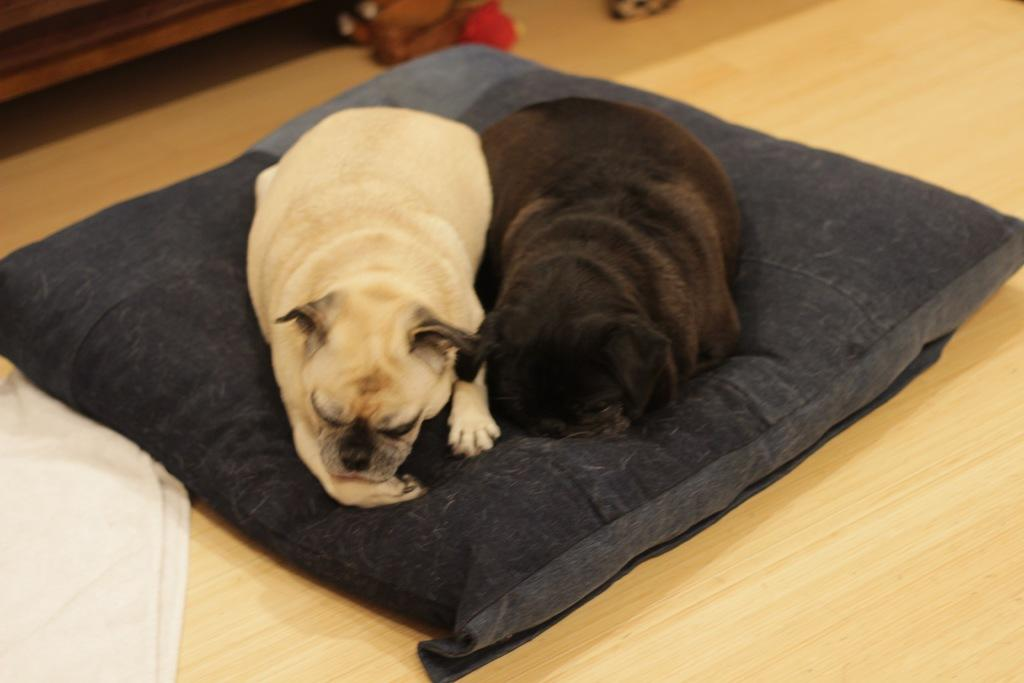How many dogs are present in the image? There are two dogs in the image. What are the dogs doing in the image? The dogs are sleeping. Where are the dogs resting in the image? The dogs are on a pillow. What is the color of the pillow? The pillow is black in color. Where is the park located in the image? There is no park present in the image. What is the birth date of the dogs in the image? The image does not provide information about the dogs' birth dates. 